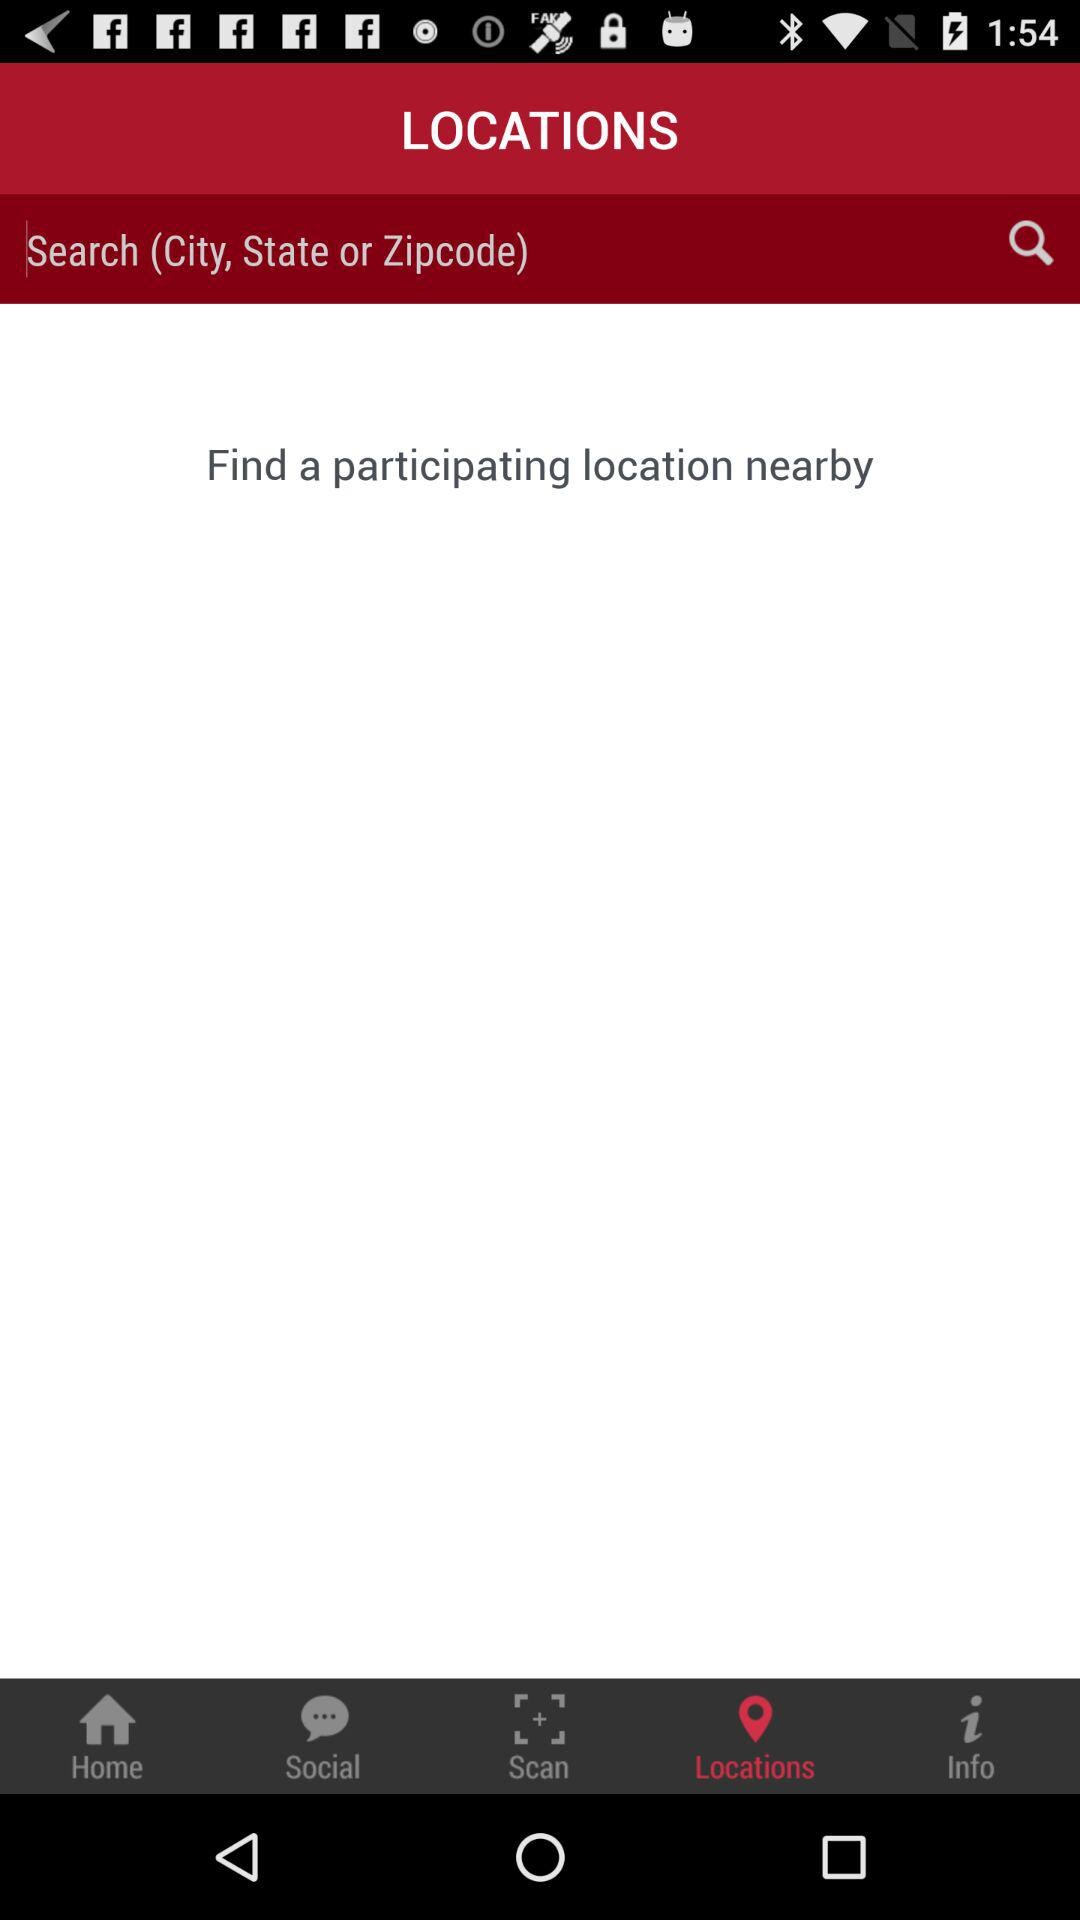Which tab is selected? The selected tab is "Locations". 